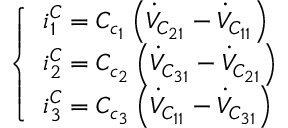Convert formula to latex. <formula><loc_0><loc_0><loc_500><loc_500>\left \{ \begin{array} { l } { i _ { 1 } ^ { C } = C _ { c _ { 1 } } \left ( \dot { V } _ { C _ { 2 1 } } - \dot { V } _ { C _ { 1 1 } } \right ) } \\ { i _ { 2 } ^ { C } = C _ { c _ { 2 } } \left ( \dot { V } _ { C _ { 3 1 } } - \dot { V } _ { C _ { 2 1 } } \right ) } \\ { i _ { 3 } ^ { C } = C _ { c _ { 3 } } \left ( \dot { V } _ { C _ { 1 1 } } - \dot { V } _ { C _ { 3 1 } } \right ) } \end{array}</formula> 